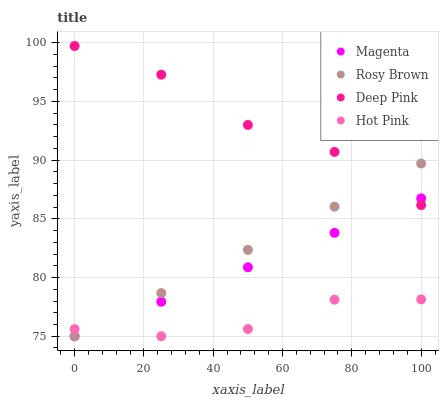Does Hot Pink have the minimum area under the curve?
Answer yes or no. Yes. Does Deep Pink have the maximum area under the curve?
Answer yes or no. Yes. Does Rosy Brown have the minimum area under the curve?
Answer yes or no. No. Does Rosy Brown have the maximum area under the curve?
Answer yes or no. No. Is Magenta the smoothest?
Answer yes or no. Yes. Is Deep Pink the roughest?
Answer yes or no. Yes. Is Rosy Brown the smoothest?
Answer yes or no. No. Is Rosy Brown the roughest?
Answer yes or no. No. Does Magenta have the lowest value?
Answer yes or no. Yes. Does Deep Pink have the lowest value?
Answer yes or no. No. Does Deep Pink have the highest value?
Answer yes or no. Yes. Does Rosy Brown have the highest value?
Answer yes or no. No. Is Hot Pink less than Deep Pink?
Answer yes or no. Yes. Is Deep Pink greater than Hot Pink?
Answer yes or no. Yes. Does Rosy Brown intersect Deep Pink?
Answer yes or no. Yes. Is Rosy Brown less than Deep Pink?
Answer yes or no. No. Is Rosy Brown greater than Deep Pink?
Answer yes or no. No. Does Hot Pink intersect Deep Pink?
Answer yes or no. No. 